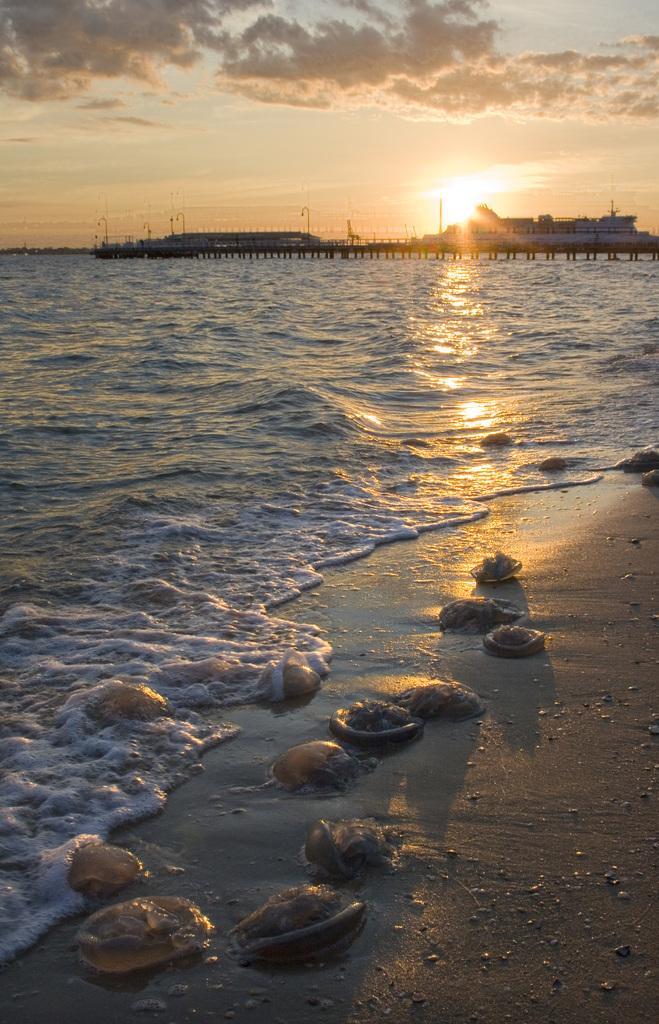How would you summarize this image in a sentence or two? Here we can see sea shells. There are ships on the water. In the background there is sky with clouds. 